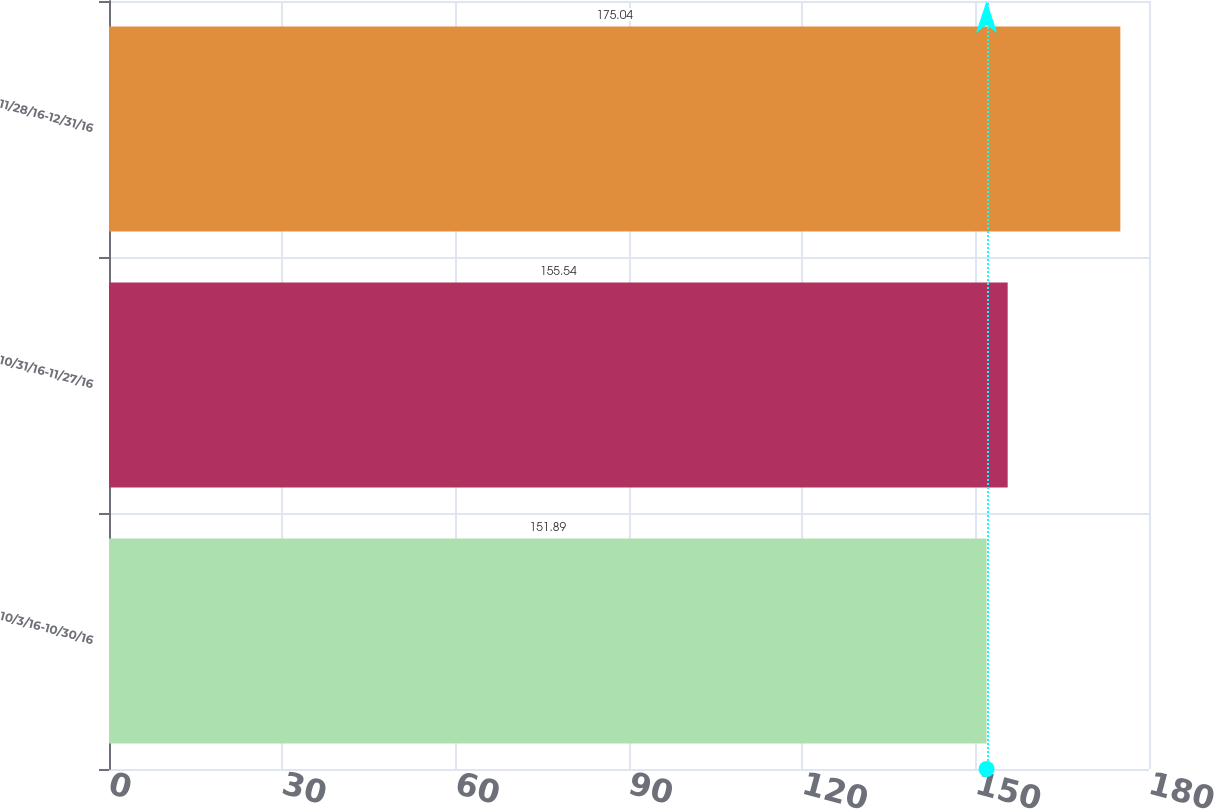Convert chart. <chart><loc_0><loc_0><loc_500><loc_500><bar_chart><fcel>10/3/16-10/30/16<fcel>10/31/16-11/27/16<fcel>11/28/16-12/31/16<nl><fcel>151.89<fcel>155.54<fcel>175.04<nl></chart> 